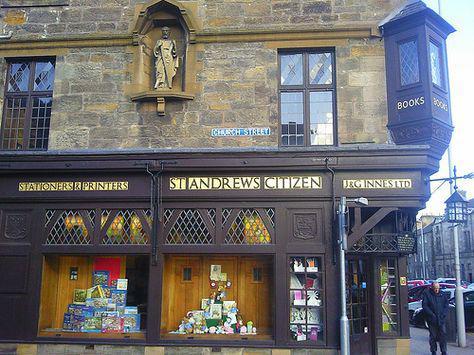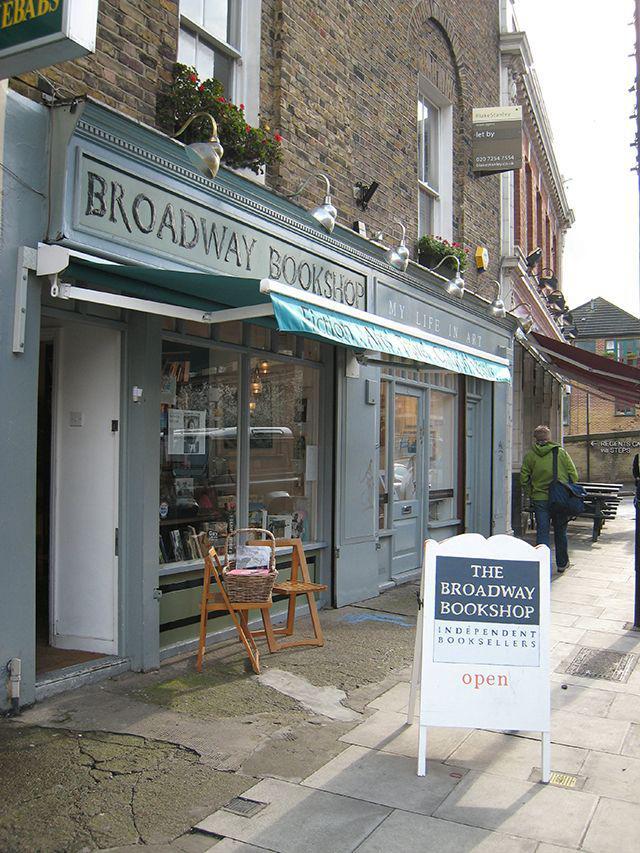The first image is the image on the left, the second image is the image on the right. Given the left and right images, does the statement "A bookstore exterior has lattice above big display windows, a shield shape over paned glass, and a statue of a figure inset in an arch on the building's front." hold true? Answer yes or no. Yes. The first image is the image on the left, the second image is the image on the right. For the images shown, is this caption "Atleast one door is brown" true? Answer yes or no. Yes. 